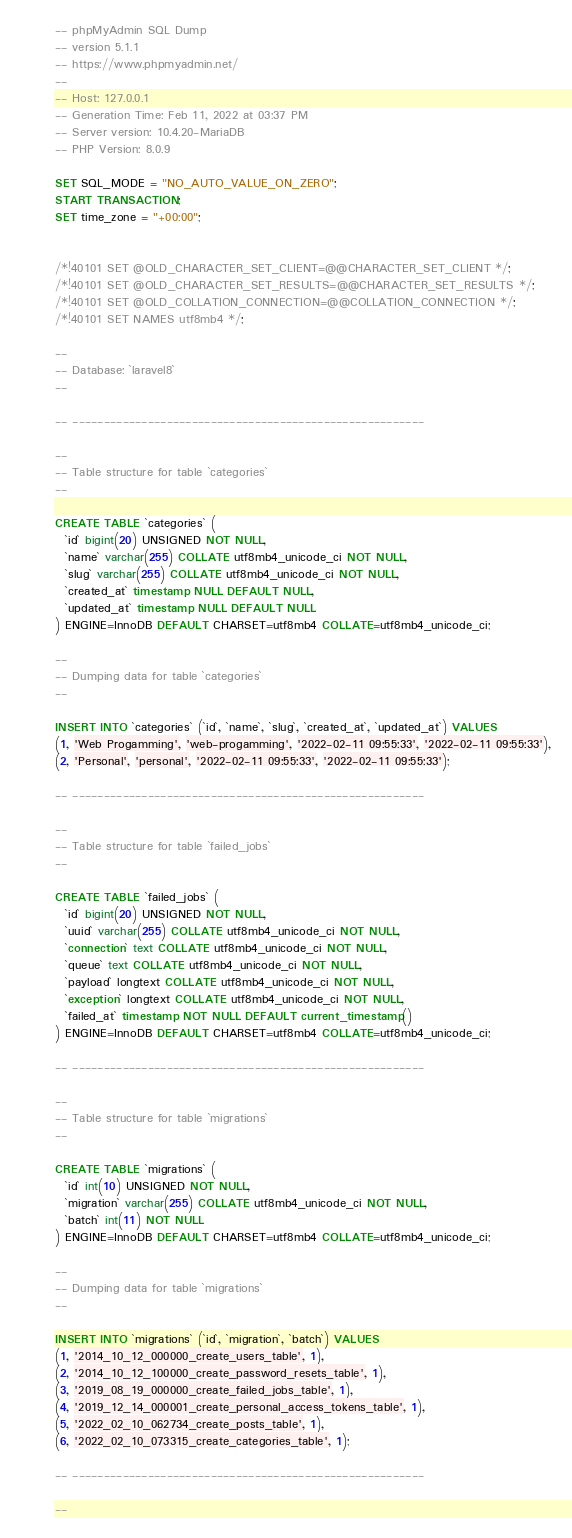<code> <loc_0><loc_0><loc_500><loc_500><_SQL_>-- phpMyAdmin SQL Dump
-- version 5.1.1
-- https://www.phpmyadmin.net/
--
-- Host: 127.0.0.1
-- Generation Time: Feb 11, 2022 at 03:37 PM
-- Server version: 10.4.20-MariaDB
-- PHP Version: 8.0.9

SET SQL_MODE = "NO_AUTO_VALUE_ON_ZERO";
START TRANSACTION;
SET time_zone = "+00:00";


/*!40101 SET @OLD_CHARACTER_SET_CLIENT=@@CHARACTER_SET_CLIENT */;
/*!40101 SET @OLD_CHARACTER_SET_RESULTS=@@CHARACTER_SET_RESULTS */;
/*!40101 SET @OLD_COLLATION_CONNECTION=@@COLLATION_CONNECTION */;
/*!40101 SET NAMES utf8mb4 */;

--
-- Database: `laravel8`
--

-- --------------------------------------------------------

--
-- Table structure for table `categories`
--

CREATE TABLE `categories` (
  `id` bigint(20) UNSIGNED NOT NULL,
  `name` varchar(255) COLLATE utf8mb4_unicode_ci NOT NULL,
  `slug` varchar(255) COLLATE utf8mb4_unicode_ci NOT NULL,
  `created_at` timestamp NULL DEFAULT NULL,
  `updated_at` timestamp NULL DEFAULT NULL
) ENGINE=InnoDB DEFAULT CHARSET=utf8mb4 COLLATE=utf8mb4_unicode_ci;

--
-- Dumping data for table `categories`
--

INSERT INTO `categories` (`id`, `name`, `slug`, `created_at`, `updated_at`) VALUES
(1, 'Web Progamming', 'web-progamming', '2022-02-11 09:55:33', '2022-02-11 09:55:33'),
(2, 'Personal', 'personal', '2022-02-11 09:55:33', '2022-02-11 09:55:33');

-- --------------------------------------------------------

--
-- Table structure for table `failed_jobs`
--

CREATE TABLE `failed_jobs` (
  `id` bigint(20) UNSIGNED NOT NULL,
  `uuid` varchar(255) COLLATE utf8mb4_unicode_ci NOT NULL,
  `connection` text COLLATE utf8mb4_unicode_ci NOT NULL,
  `queue` text COLLATE utf8mb4_unicode_ci NOT NULL,
  `payload` longtext COLLATE utf8mb4_unicode_ci NOT NULL,
  `exception` longtext COLLATE utf8mb4_unicode_ci NOT NULL,
  `failed_at` timestamp NOT NULL DEFAULT current_timestamp()
) ENGINE=InnoDB DEFAULT CHARSET=utf8mb4 COLLATE=utf8mb4_unicode_ci;

-- --------------------------------------------------------

--
-- Table structure for table `migrations`
--

CREATE TABLE `migrations` (
  `id` int(10) UNSIGNED NOT NULL,
  `migration` varchar(255) COLLATE utf8mb4_unicode_ci NOT NULL,
  `batch` int(11) NOT NULL
) ENGINE=InnoDB DEFAULT CHARSET=utf8mb4 COLLATE=utf8mb4_unicode_ci;

--
-- Dumping data for table `migrations`
--

INSERT INTO `migrations` (`id`, `migration`, `batch`) VALUES
(1, '2014_10_12_000000_create_users_table', 1),
(2, '2014_10_12_100000_create_password_resets_table', 1),
(3, '2019_08_19_000000_create_failed_jobs_table', 1),
(4, '2019_12_14_000001_create_personal_access_tokens_table', 1),
(5, '2022_02_10_062734_create_posts_table', 1),
(6, '2022_02_10_073315_create_categories_table', 1);

-- --------------------------------------------------------

--</code> 